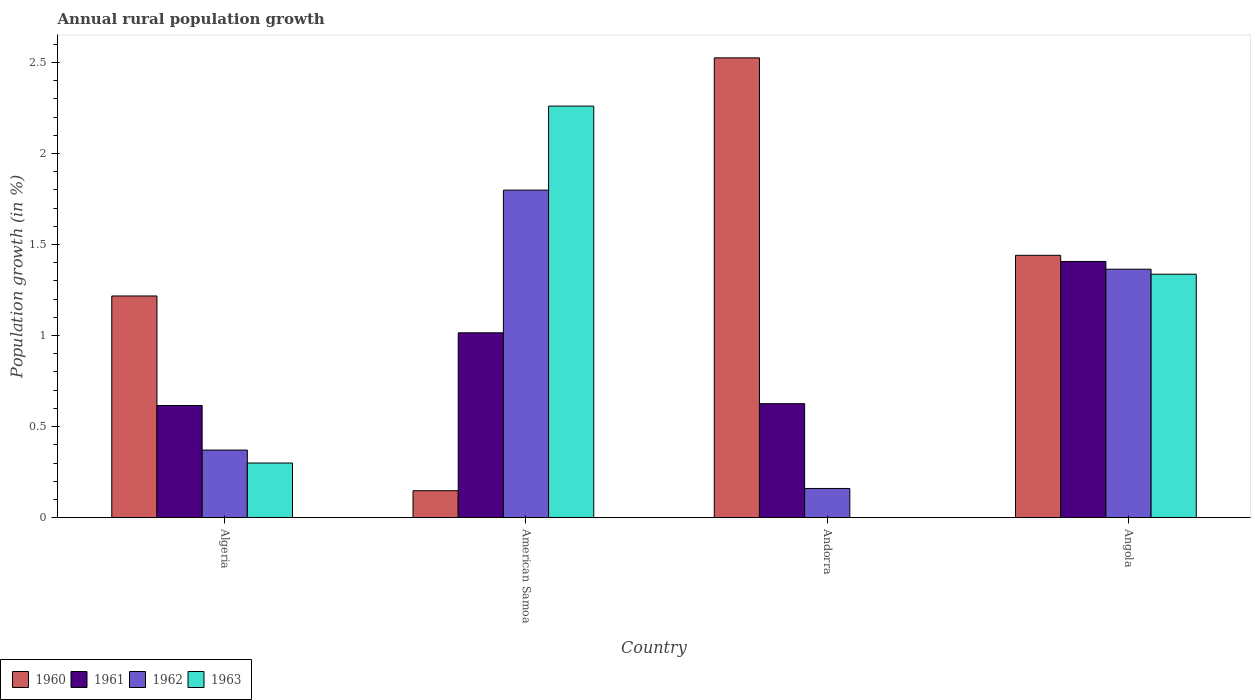How many different coloured bars are there?
Keep it short and to the point. 4. How many groups of bars are there?
Make the answer very short. 4. Are the number of bars on each tick of the X-axis equal?
Provide a succinct answer. No. What is the label of the 1st group of bars from the left?
Your answer should be very brief. Algeria. What is the percentage of rural population growth in 1963 in American Samoa?
Your answer should be compact. 2.26. Across all countries, what is the maximum percentage of rural population growth in 1962?
Provide a succinct answer. 1.8. Across all countries, what is the minimum percentage of rural population growth in 1960?
Offer a very short reply. 0.15. In which country was the percentage of rural population growth in 1960 maximum?
Your answer should be compact. Andorra. What is the total percentage of rural population growth in 1963 in the graph?
Make the answer very short. 3.9. What is the difference between the percentage of rural population growth in 1961 in Andorra and that in Angola?
Offer a terse response. -0.78. What is the difference between the percentage of rural population growth in 1962 in Andorra and the percentage of rural population growth in 1963 in American Samoa?
Offer a terse response. -2.1. What is the average percentage of rural population growth in 1961 per country?
Offer a terse response. 0.92. What is the difference between the percentage of rural population growth of/in 1963 and percentage of rural population growth of/in 1962 in Algeria?
Provide a succinct answer. -0.07. In how many countries, is the percentage of rural population growth in 1961 greater than 1.7 %?
Your answer should be very brief. 0. What is the ratio of the percentage of rural population growth in 1960 in Andorra to that in Angola?
Offer a very short reply. 1.75. Is the difference between the percentage of rural population growth in 1963 in Algeria and American Samoa greater than the difference between the percentage of rural population growth in 1962 in Algeria and American Samoa?
Your response must be concise. No. What is the difference between the highest and the second highest percentage of rural population growth in 1961?
Your answer should be very brief. -0.78. What is the difference between the highest and the lowest percentage of rural population growth in 1961?
Your answer should be very brief. 0.79. Is the sum of the percentage of rural population growth in 1961 in American Samoa and Andorra greater than the maximum percentage of rural population growth in 1960 across all countries?
Your answer should be compact. No. Is it the case that in every country, the sum of the percentage of rural population growth in 1962 and percentage of rural population growth in 1960 is greater than the sum of percentage of rural population growth in 1961 and percentage of rural population growth in 1963?
Your answer should be compact. No. Is it the case that in every country, the sum of the percentage of rural population growth in 1961 and percentage of rural population growth in 1962 is greater than the percentage of rural population growth in 1960?
Your answer should be very brief. No. Are all the bars in the graph horizontal?
Your answer should be compact. No. How many countries are there in the graph?
Provide a short and direct response. 4. Are the values on the major ticks of Y-axis written in scientific E-notation?
Your answer should be very brief. No. Where does the legend appear in the graph?
Offer a terse response. Bottom left. How many legend labels are there?
Make the answer very short. 4. What is the title of the graph?
Provide a short and direct response. Annual rural population growth. Does "1979" appear as one of the legend labels in the graph?
Provide a succinct answer. No. What is the label or title of the Y-axis?
Provide a short and direct response. Population growth (in %). What is the Population growth (in %) of 1960 in Algeria?
Make the answer very short. 1.22. What is the Population growth (in %) in 1961 in Algeria?
Your response must be concise. 0.62. What is the Population growth (in %) in 1962 in Algeria?
Give a very brief answer. 0.37. What is the Population growth (in %) of 1963 in Algeria?
Offer a very short reply. 0.3. What is the Population growth (in %) in 1960 in American Samoa?
Offer a very short reply. 0.15. What is the Population growth (in %) in 1961 in American Samoa?
Provide a succinct answer. 1.02. What is the Population growth (in %) of 1962 in American Samoa?
Keep it short and to the point. 1.8. What is the Population growth (in %) of 1963 in American Samoa?
Your answer should be very brief. 2.26. What is the Population growth (in %) in 1960 in Andorra?
Give a very brief answer. 2.53. What is the Population growth (in %) in 1961 in Andorra?
Your response must be concise. 0.63. What is the Population growth (in %) of 1962 in Andorra?
Provide a succinct answer. 0.16. What is the Population growth (in %) in 1963 in Andorra?
Offer a terse response. 0. What is the Population growth (in %) in 1960 in Angola?
Your response must be concise. 1.44. What is the Population growth (in %) of 1961 in Angola?
Provide a short and direct response. 1.41. What is the Population growth (in %) in 1962 in Angola?
Ensure brevity in your answer.  1.36. What is the Population growth (in %) of 1963 in Angola?
Make the answer very short. 1.34. Across all countries, what is the maximum Population growth (in %) in 1960?
Make the answer very short. 2.53. Across all countries, what is the maximum Population growth (in %) in 1961?
Provide a short and direct response. 1.41. Across all countries, what is the maximum Population growth (in %) of 1962?
Give a very brief answer. 1.8. Across all countries, what is the maximum Population growth (in %) of 1963?
Offer a terse response. 2.26. Across all countries, what is the minimum Population growth (in %) of 1960?
Your answer should be very brief. 0.15. Across all countries, what is the minimum Population growth (in %) of 1961?
Provide a succinct answer. 0.62. Across all countries, what is the minimum Population growth (in %) of 1962?
Make the answer very short. 0.16. Across all countries, what is the minimum Population growth (in %) in 1963?
Offer a terse response. 0. What is the total Population growth (in %) of 1960 in the graph?
Keep it short and to the point. 5.33. What is the total Population growth (in %) of 1961 in the graph?
Provide a succinct answer. 3.66. What is the total Population growth (in %) of 1962 in the graph?
Ensure brevity in your answer.  3.7. What is the total Population growth (in %) of 1963 in the graph?
Provide a succinct answer. 3.9. What is the difference between the Population growth (in %) in 1960 in Algeria and that in American Samoa?
Provide a short and direct response. 1.07. What is the difference between the Population growth (in %) in 1961 in Algeria and that in American Samoa?
Ensure brevity in your answer.  -0.4. What is the difference between the Population growth (in %) of 1962 in Algeria and that in American Samoa?
Give a very brief answer. -1.43. What is the difference between the Population growth (in %) of 1963 in Algeria and that in American Samoa?
Make the answer very short. -1.96. What is the difference between the Population growth (in %) of 1960 in Algeria and that in Andorra?
Provide a short and direct response. -1.31. What is the difference between the Population growth (in %) of 1961 in Algeria and that in Andorra?
Offer a very short reply. -0.01. What is the difference between the Population growth (in %) of 1962 in Algeria and that in Andorra?
Your response must be concise. 0.21. What is the difference between the Population growth (in %) in 1960 in Algeria and that in Angola?
Provide a succinct answer. -0.22. What is the difference between the Population growth (in %) of 1961 in Algeria and that in Angola?
Your answer should be compact. -0.79. What is the difference between the Population growth (in %) in 1962 in Algeria and that in Angola?
Offer a very short reply. -0.99. What is the difference between the Population growth (in %) of 1963 in Algeria and that in Angola?
Provide a succinct answer. -1.04. What is the difference between the Population growth (in %) in 1960 in American Samoa and that in Andorra?
Provide a short and direct response. -2.38. What is the difference between the Population growth (in %) in 1961 in American Samoa and that in Andorra?
Offer a terse response. 0.39. What is the difference between the Population growth (in %) in 1962 in American Samoa and that in Andorra?
Your response must be concise. 1.64. What is the difference between the Population growth (in %) in 1960 in American Samoa and that in Angola?
Ensure brevity in your answer.  -1.29. What is the difference between the Population growth (in %) in 1961 in American Samoa and that in Angola?
Give a very brief answer. -0.39. What is the difference between the Population growth (in %) in 1962 in American Samoa and that in Angola?
Ensure brevity in your answer.  0.43. What is the difference between the Population growth (in %) of 1963 in American Samoa and that in Angola?
Your answer should be compact. 0.92. What is the difference between the Population growth (in %) of 1960 in Andorra and that in Angola?
Give a very brief answer. 1.08. What is the difference between the Population growth (in %) of 1961 in Andorra and that in Angola?
Your answer should be compact. -0.78. What is the difference between the Population growth (in %) in 1962 in Andorra and that in Angola?
Make the answer very short. -1.2. What is the difference between the Population growth (in %) of 1960 in Algeria and the Population growth (in %) of 1961 in American Samoa?
Make the answer very short. 0.2. What is the difference between the Population growth (in %) of 1960 in Algeria and the Population growth (in %) of 1962 in American Samoa?
Your response must be concise. -0.58. What is the difference between the Population growth (in %) in 1960 in Algeria and the Population growth (in %) in 1963 in American Samoa?
Provide a short and direct response. -1.04. What is the difference between the Population growth (in %) in 1961 in Algeria and the Population growth (in %) in 1962 in American Samoa?
Make the answer very short. -1.18. What is the difference between the Population growth (in %) in 1961 in Algeria and the Population growth (in %) in 1963 in American Samoa?
Give a very brief answer. -1.64. What is the difference between the Population growth (in %) in 1962 in Algeria and the Population growth (in %) in 1963 in American Samoa?
Your answer should be compact. -1.89. What is the difference between the Population growth (in %) in 1960 in Algeria and the Population growth (in %) in 1961 in Andorra?
Provide a short and direct response. 0.59. What is the difference between the Population growth (in %) in 1960 in Algeria and the Population growth (in %) in 1962 in Andorra?
Offer a very short reply. 1.06. What is the difference between the Population growth (in %) in 1961 in Algeria and the Population growth (in %) in 1962 in Andorra?
Ensure brevity in your answer.  0.46. What is the difference between the Population growth (in %) in 1960 in Algeria and the Population growth (in %) in 1961 in Angola?
Offer a very short reply. -0.19. What is the difference between the Population growth (in %) of 1960 in Algeria and the Population growth (in %) of 1962 in Angola?
Provide a short and direct response. -0.15. What is the difference between the Population growth (in %) in 1960 in Algeria and the Population growth (in %) in 1963 in Angola?
Make the answer very short. -0.12. What is the difference between the Population growth (in %) in 1961 in Algeria and the Population growth (in %) in 1962 in Angola?
Ensure brevity in your answer.  -0.75. What is the difference between the Population growth (in %) in 1961 in Algeria and the Population growth (in %) in 1963 in Angola?
Keep it short and to the point. -0.72. What is the difference between the Population growth (in %) in 1962 in Algeria and the Population growth (in %) in 1963 in Angola?
Provide a succinct answer. -0.97. What is the difference between the Population growth (in %) in 1960 in American Samoa and the Population growth (in %) in 1961 in Andorra?
Offer a terse response. -0.48. What is the difference between the Population growth (in %) of 1960 in American Samoa and the Population growth (in %) of 1962 in Andorra?
Offer a very short reply. -0.01. What is the difference between the Population growth (in %) of 1961 in American Samoa and the Population growth (in %) of 1962 in Andorra?
Your answer should be compact. 0.85. What is the difference between the Population growth (in %) in 1960 in American Samoa and the Population growth (in %) in 1961 in Angola?
Offer a very short reply. -1.26. What is the difference between the Population growth (in %) of 1960 in American Samoa and the Population growth (in %) of 1962 in Angola?
Your answer should be very brief. -1.22. What is the difference between the Population growth (in %) in 1960 in American Samoa and the Population growth (in %) in 1963 in Angola?
Your response must be concise. -1.19. What is the difference between the Population growth (in %) of 1961 in American Samoa and the Population growth (in %) of 1962 in Angola?
Offer a very short reply. -0.35. What is the difference between the Population growth (in %) of 1961 in American Samoa and the Population growth (in %) of 1963 in Angola?
Offer a very short reply. -0.32. What is the difference between the Population growth (in %) in 1962 in American Samoa and the Population growth (in %) in 1963 in Angola?
Offer a terse response. 0.46. What is the difference between the Population growth (in %) in 1960 in Andorra and the Population growth (in %) in 1961 in Angola?
Offer a terse response. 1.12. What is the difference between the Population growth (in %) of 1960 in Andorra and the Population growth (in %) of 1962 in Angola?
Keep it short and to the point. 1.16. What is the difference between the Population growth (in %) in 1960 in Andorra and the Population growth (in %) in 1963 in Angola?
Provide a succinct answer. 1.19. What is the difference between the Population growth (in %) in 1961 in Andorra and the Population growth (in %) in 1962 in Angola?
Offer a terse response. -0.74. What is the difference between the Population growth (in %) in 1961 in Andorra and the Population growth (in %) in 1963 in Angola?
Offer a terse response. -0.71. What is the difference between the Population growth (in %) in 1962 in Andorra and the Population growth (in %) in 1963 in Angola?
Keep it short and to the point. -1.18. What is the average Population growth (in %) of 1960 per country?
Provide a succinct answer. 1.33. What is the average Population growth (in %) of 1961 per country?
Your answer should be very brief. 0.92. What is the average Population growth (in %) of 1962 per country?
Keep it short and to the point. 0.92. What is the average Population growth (in %) of 1963 per country?
Provide a short and direct response. 0.97. What is the difference between the Population growth (in %) in 1960 and Population growth (in %) in 1961 in Algeria?
Your answer should be compact. 0.6. What is the difference between the Population growth (in %) of 1960 and Population growth (in %) of 1962 in Algeria?
Provide a short and direct response. 0.85. What is the difference between the Population growth (in %) in 1960 and Population growth (in %) in 1963 in Algeria?
Ensure brevity in your answer.  0.92. What is the difference between the Population growth (in %) of 1961 and Population growth (in %) of 1962 in Algeria?
Your response must be concise. 0.24. What is the difference between the Population growth (in %) in 1961 and Population growth (in %) in 1963 in Algeria?
Give a very brief answer. 0.32. What is the difference between the Population growth (in %) in 1962 and Population growth (in %) in 1963 in Algeria?
Your response must be concise. 0.07. What is the difference between the Population growth (in %) of 1960 and Population growth (in %) of 1961 in American Samoa?
Offer a terse response. -0.87. What is the difference between the Population growth (in %) in 1960 and Population growth (in %) in 1962 in American Samoa?
Keep it short and to the point. -1.65. What is the difference between the Population growth (in %) in 1960 and Population growth (in %) in 1963 in American Samoa?
Your answer should be very brief. -2.11. What is the difference between the Population growth (in %) in 1961 and Population growth (in %) in 1962 in American Samoa?
Ensure brevity in your answer.  -0.78. What is the difference between the Population growth (in %) of 1961 and Population growth (in %) of 1963 in American Samoa?
Provide a succinct answer. -1.25. What is the difference between the Population growth (in %) of 1962 and Population growth (in %) of 1963 in American Samoa?
Provide a short and direct response. -0.46. What is the difference between the Population growth (in %) in 1960 and Population growth (in %) in 1961 in Andorra?
Offer a very short reply. 1.9. What is the difference between the Population growth (in %) in 1960 and Population growth (in %) in 1962 in Andorra?
Your answer should be compact. 2.37. What is the difference between the Population growth (in %) in 1961 and Population growth (in %) in 1962 in Andorra?
Provide a succinct answer. 0.47. What is the difference between the Population growth (in %) of 1960 and Population growth (in %) of 1961 in Angola?
Offer a very short reply. 0.03. What is the difference between the Population growth (in %) of 1960 and Population growth (in %) of 1962 in Angola?
Your answer should be compact. 0.08. What is the difference between the Population growth (in %) of 1960 and Population growth (in %) of 1963 in Angola?
Your answer should be very brief. 0.1. What is the difference between the Population growth (in %) in 1961 and Population growth (in %) in 1962 in Angola?
Offer a terse response. 0.04. What is the difference between the Population growth (in %) in 1961 and Population growth (in %) in 1963 in Angola?
Make the answer very short. 0.07. What is the difference between the Population growth (in %) of 1962 and Population growth (in %) of 1963 in Angola?
Keep it short and to the point. 0.03. What is the ratio of the Population growth (in %) in 1960 in Algeria to that in American Samoa?
Give a very brief answer. 8.23. What is the ratio of the Population growth (in %) in 1961 in Algeria to that in American Samoa?
Make the answer very short. 0.61. What is the ratio of the Population growth (in %) in 1962 in Algeria to that in American Samoa?
Give a very brief answer. 0.21. What is the ratio of the Population growth (in %) in 1963 in Algeria to that in American Samoa?
Provide a short and direct response. 0.13. What is the ratio of the Population growth (in %) of 1960 in Algeria to that in Andorra?
Ensure brevity in your answer.  0.48. What is the ratio of the Population growth (in %) of 1961 in Algeria to that in Andorra?
Offer a terse response. 0.98. What is the ratio of the Population growth (in %) in 1962 in Algeria to that in Andorra?
Your response must be concise. 2.32. What is the ratio of the Population growth (in %) in 1960 in Algeria to that in Angola?
Offer a terse response. 0.84. What is the ratio of the Population growth (in %) in 1961 in Algeria to that in Angola?
Offer a very short reply. 0.44. What is the ratio of the Population growth (in %) of 1962 in Algeria to that in Angola?
Offer a terse response. 0.27. What is the ratio of the Population growth (in %) in 1963 in Algeria to that in Angola?
Ensure brevity in your answer.  0.22. What is the ratio of the Population growth (in %) of 1960 in American Samoa to that in Andorra?
Provide a short and direct response. 0.06. What is the ratio of the Population growth (in %) of 1961 in American Samoa to that in Andorra?
Your response must be concise. 1.62. What is the ratio of the Population growth (in %) of 1962 in American Samoa to that in Andorra?
Your response must be concise. 11.22. What is the ratio of the Population growth (in %) in 1960 in American Samoa to that in Angola?
Give a very brief answer. 0.1. What is the ratio of the Population growth (in %) of 1961 in American Samoa to that in Angola?
Your answer should be compact. 0.72. What is the ratio of the Population growth (in %) of 1962 in American Samoa to that in Angola?
Offer a terse response. 1.32. What is the ratio of the Population growth (in %) of 1963 in American Samoa to that in Angola?
Offer a terse response. 1.69. What is the ratio of the Population growth (in %) in 1960 in Andorra to that in Angola?
Your answer should be compact. 1.75. What is the ratio of the Population growth (in %) of 1961 in Andorra to that in Angola?
Provide a succinct answer. 0.44. What is the ratio of the Population growth (in %) in 1962 in Andorra to that in Angola?
Provide a succinct answer. 0.12. What is the difference between the highest and the second highest Population growth (in %) in 1960?
Give a very brief answer. 1.08. What is the difference between the highest and the second highest Population growth (in %) of 1961?
Your answer should be very brief. 0.39. What is the difference between the highest and the second highest Population growth (in %) of 1962?
Offer a terse response. 0.43. What is the difference between the highest and the second highest Population growth (in %) in 1963?
Provide a short and direct response. 0.92. What is the difference between the highest and the lowest Population growth (in %) in 1960?
Your answer should be very brief. 2.38. What is the difference between the highest and the lowest Population growth (in %) in 1961?
Keep it short and to the point. 0.79. What is the difference between the highest and the lowest Population growth (in %) of 1962?
Keep it short and to the point. 1.64. What is the difference between the highest and the lowest Population growth (in %) in 1963?
Ensure brevity in your answer.  2.26. 